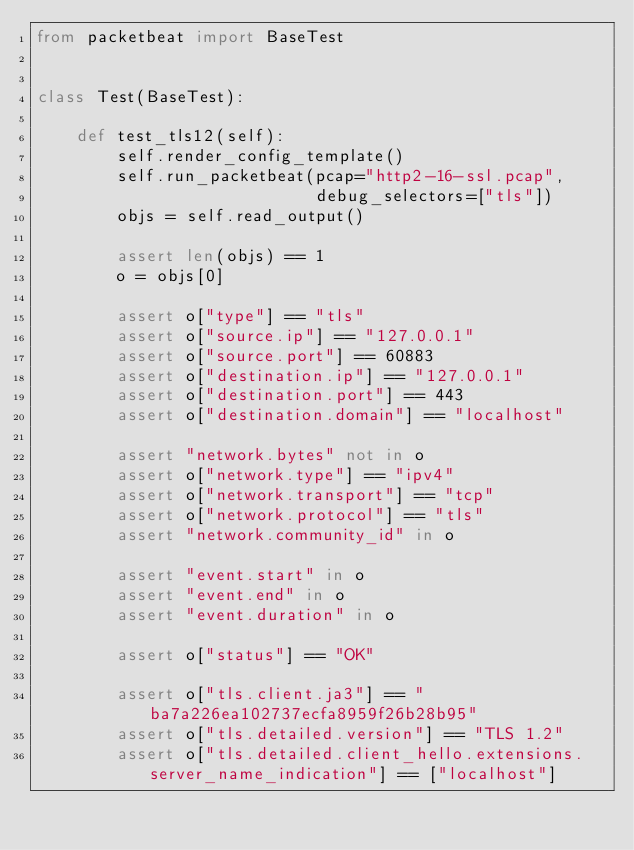Convert code to text. <code><loc_0><loc_0><loc_500><loc_500><_Python_>from packetbeat import BaseTest


class Test(BaseTest):

    def test_tls12(self):
        self.render_config_template()
        self.run_packetbeat(pcap="http2-16-ssl.pcap",
                            debug_selectors=["tls"])
        objs = self.read_output()

        assert len(objs) == 1
        o = objs[0]

        assert o["type"] == "tls"
        assert o["source.ip"] == "127.0.0.1"
        assert o["source.port"] == 60883
        assert o["destination.ip"] == "127.0.0.1"
        assert o["destination.port"] == 443
        assert o["destination.domain"] == "localhost"

        assert "network.bytes" not in o
        assert o["network.type"] == "ipv4"
        assert o["network.transport"] == "tcp"
        assert o["network.protocol"] == "tls"
        assert "network.community_id" in o

        assert "event.start" in o
        assert "event.end" in o
        assert "event.duration" in o

        assert o["status"] == "OK"

        assert o["tls.client.ja3"] == "ba7a226ea102737ecfa8959f26b28b95"
        assert o["tls.detailed.version"] == "TLS 1.2"
        assert o["tls.detailed.client_hello.extensions.server_name_indication"] == ["localhost"]
</code> 